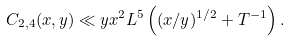Convert formula to latex. <formula><loc_0><loc_0><loc_500><loc_500>C _ { 2 , 4 } ( x , y ) & \ll y x ^ { 2 } L ^ { 5 } \left ( ( x / y ) ^ { 1 / 2 } + T ^ { - 1 } \right ) .</formula> 